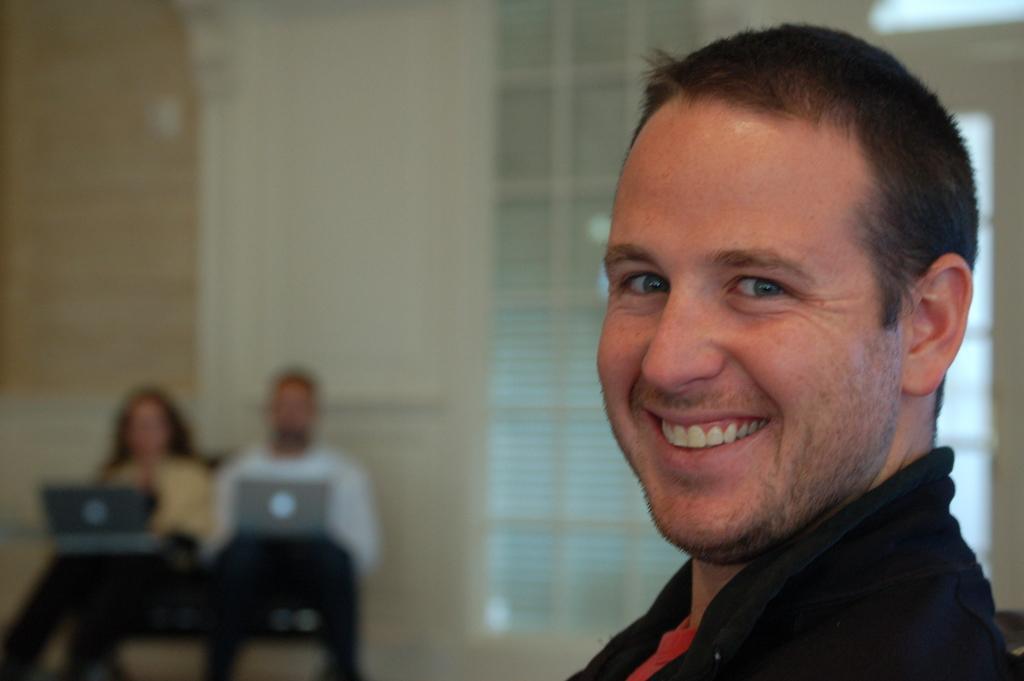Could you give a brief overview of what you see in this image? In this image we can see there is a person with a smile on his face. In the background there are two persons placed their laptops on their lap, behind them there is a wall. 